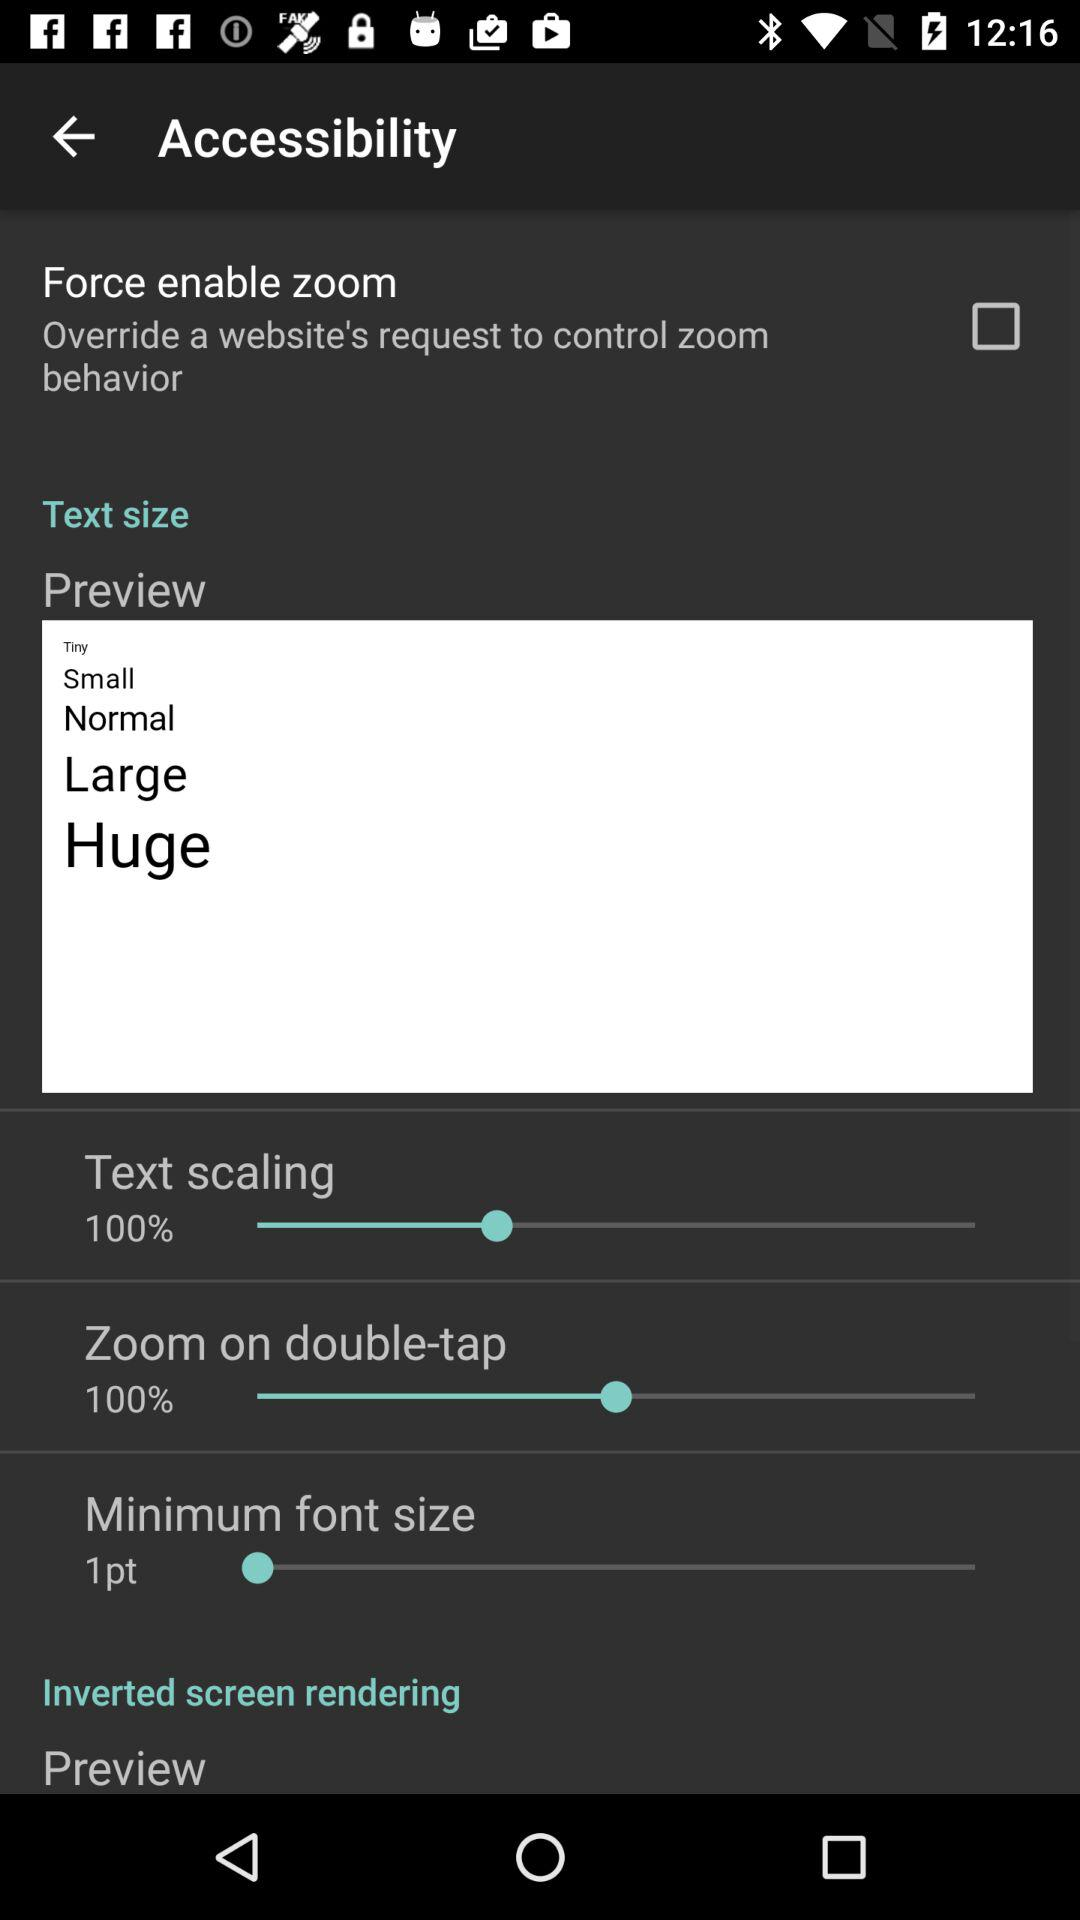How much is the maximum font size in points?
When the provided information is insufficient, respond with <no answer>. <no answer> 